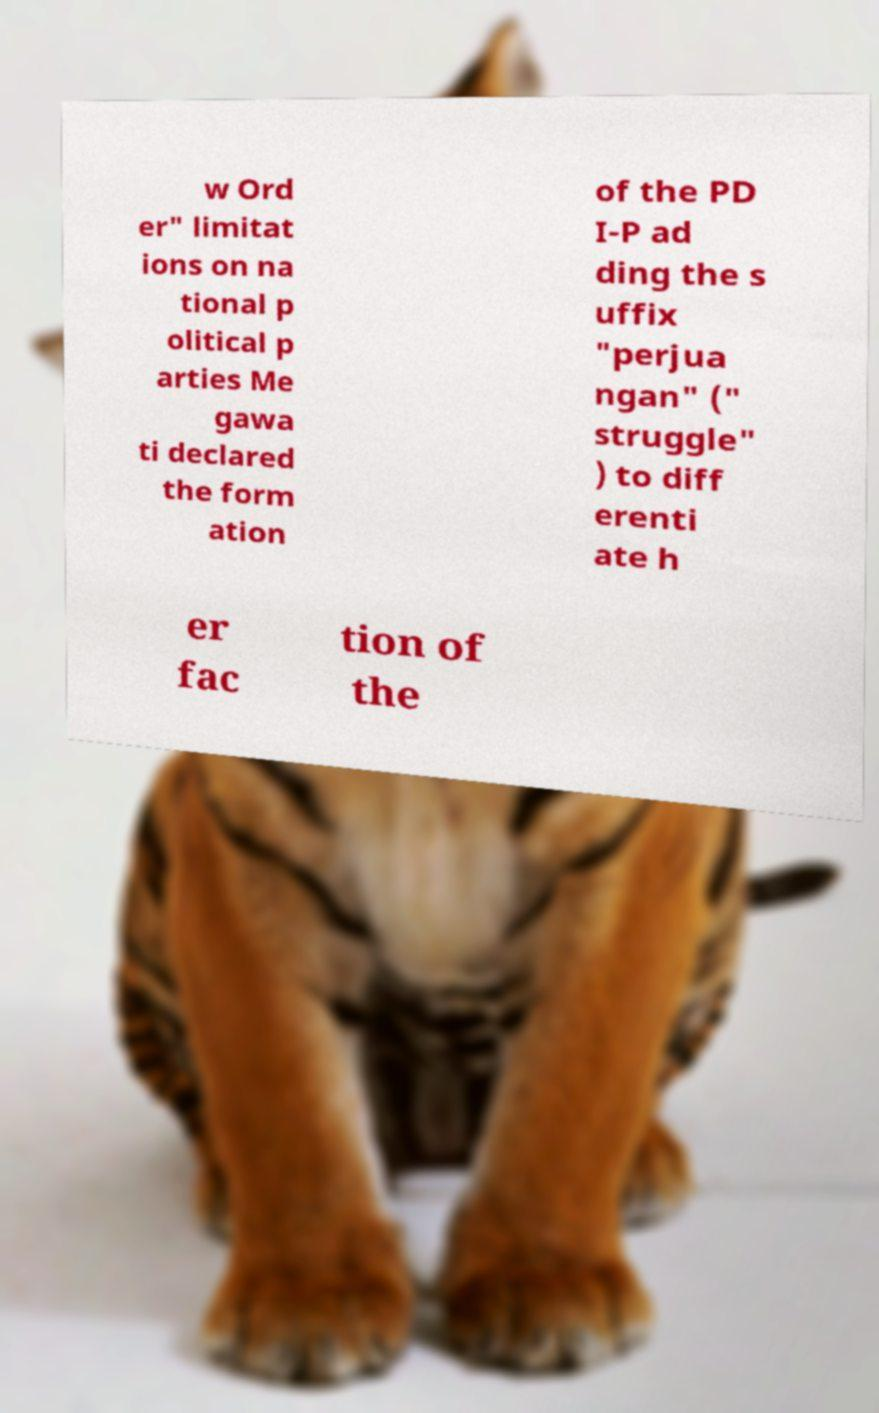I need the written content from this picture converted into text. Can you do that? w Ord er" limitat ions on na tional p olitical p arties Me gawa ti declared the form ation of the PD I-P ad ding the s uffix "perjua ngan" (" struggle" ) to diff erenti ate h er fac tion of the 